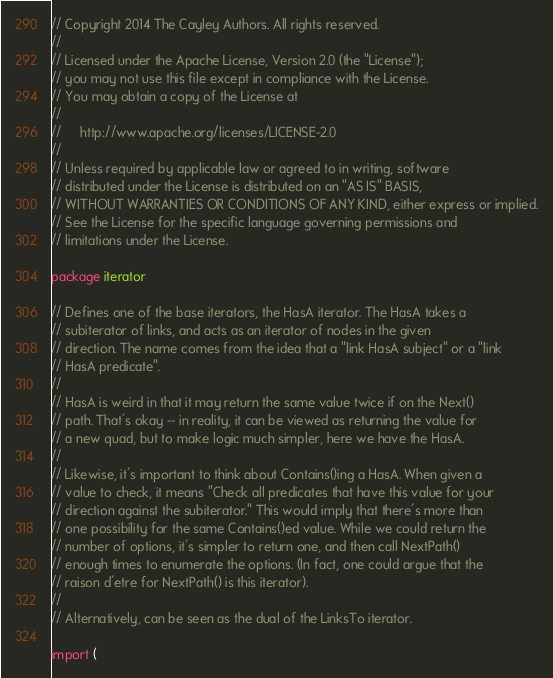Convert code to text. <code><loc_0><loc_0><loc_500><loc_500><_Go_>// Copyright 2014 The Cayley Authors. All rights reserved.
//
// Licensed under the Apache License, Version 2.0 (the "License");
// you may not use this file except in compliance with the License.
// You may obtain a copy of the License at
//
//     http://www.apache.org/licenses/LICENSE-2.0
//
// Unless required by applicable law or agreed to in writing, software
// distributed under the License is distributed on an "AS IS" BASIS,
// WITHOUT WARRANTIES OR CONDITIONS OF ANY KIND, either express or implied.
// See the License for the specific language governing permissions and
// limitations under the License.

package iterator

// Defines one of the base iterators, the HasA iterator. The HasA takes a
// subiterator of links, and acts as an iterator of nodes in the given
// direction. The name comes from the idea that a "link HasA subject" or a "link
// HasA predicate".
//
// HasA is weird in that it may return the same value twice if on the Next()
// path. That's okay -- in reality, it can be viewed as returning the value for
// a new quad, but to make logic much simpler, here we have the HasA.
//
// Likewise, it's important to think about Contains()ing a HasA. When given a
// value to check, it means "Check all predicates that have this value for your
// direction against the subiterator." This would imply that there's more than
// one possibility for the same Contains()ed value. While we could return the
// number of options, it's simpler to return one, and then call NextPath()
// enough times to enumerate the options. (In fact, one could argue that the
// raison d'etre for NextPath() is this iterator).
//
// Alternatively, can be seen as the dual of the LinksTo iterator.

import (</code> 